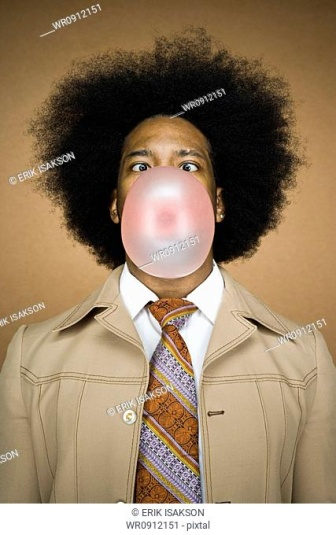If the person in the photo could speak, what humorous remark might they make about the size of the bubble? If the person in the photo could speak, they might humorously say, 'Looks like I could use this bubble as a face mask!' or 'I always knew I had a big mouth, but this is ridiculous!' 